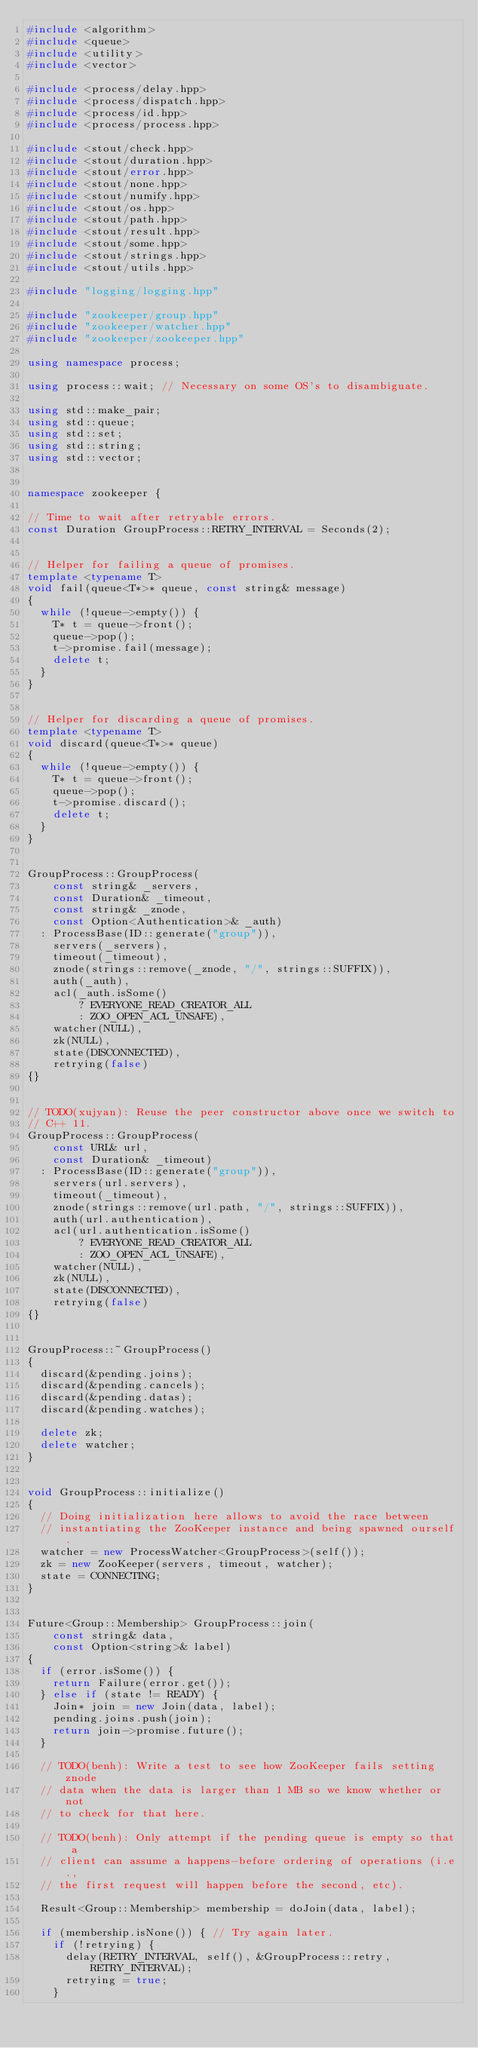<code> <loc_0><loc_0><loc_500><loc_500><_C++_>#include <algorithm>
#include <queue>
#include <utility>
#include <vector>

#include <process/delay.hpp>
#include <process/dispatch.hpp>
#include <process/id.hpp>
#include <process/process.hpp>

#include <stout/check.hpp>
#include <stout/duration.hpp>
#include <stout/error.hpp>
#include <stout/none.hpp>
#include <stout/numify.hpp>
#include <stout/os.hpp>
#include <stout/path.hpp>
#include <stout/result.hpp>
#include <stout/some.hpp>
#include <stout/strings.hpp>
#include <stout/utils.hpp>

#include "logging/logging.hpp"

#include "zookeeper/group.hpp"
#include "zookeeper/watcher.hpp"
#include "zookeeper/zookeeper.hpp"

using namespace process;

using process::wait; // Necessary on some OS's to disambiguate.

using std::make_pair;
using std::queue;
using std::set;
using std::string;
using std::vector;


namespace zookeeper {

// Time to wait after retryable errors.
const Duration GroupProcess::RETRY_INTERVAL = Seconds(2);


// Helper for failing a queue of promises.
template <typename T>
void fail(queue<T*>* queue, const string& message)
{
  while (!queue->empty()) {
    T* t = queue->front();
    queue->pop();
    t->promise.fail(message);
    delete t;
  }
}


// Helper for discarding a queue of promises.
template <typename T>
void discard(queue<T*>* queue)
{
  while (!queue->empty()) {
    T* t = queue->front();
    queue->pop();
    t->promise.discard();
    delete t;
  }
}


GroupProcess::GroupProcess(
    const string& _servers,
    const Duration& _timeout,
    const string& _znode,
    const Option<Authentication>& _auth)
  : ProcessBase(ID::generate("group")),
    servers(_servers),
    timeout(_timeout),
    znode(strings::remove(_znode, "/", strings::SUFFIX)),
    auth(_auth),
    acl(_auth.isSome()
        ? EVERYONE_READ_CREATOR_ALL
        : ZOO_OPEN_ACL_UNSAFE),
    watcher(NULL),
    zk(NULL),
    state(DISCONNECTED),
    retrying(false)
{}


// TODO(xujyan): Reuse the peer constructor above once we switch to
// C++ 11.
GroupProcess::GroupProcess(
    const URL& url,
    const Duration& _timeout)
  : ProcessBase(ID::generate("group")),
    servers(url.servers),
    timeout(_timeout),
    znode(strings::remove(url.path, "/", strings::SUFFIX)),
    auth(url.authentication),
    acl(url.authentication.isSome()
        ? EVERYONE_READ_CREATOR_ALL
        : ZOO_OPEN_ACL_UNSAFE),
    watcher(NULL),
    zk(NULL),
    state(DISCONNECTED),
    retrying(false)
{}


GroupProcess::~GroupProcess()
{
  discard(&pending.joins);
  discard(&pending.cancels);
  discard(&pending.datas);
  discard(&pending.watches);

  delete zk;
  delete watcher;
}


void GroupProcess::initialize()
{
  // Doing initialization here allows to avoid the race between
  // instantiating the ZooKeeper instance and being spawned ourself.
  watcher = new ProcessWatcher<GroupProcess>(self());
  zk = new ZooKeeper(servers, timeout, watcher);
  state = CONNECTING;
}


Future<Group::Membership> GroupProcess::join(
    const string& data,
    const Option<string>& label)
{
  if (error.isSome()) {
    return Failure(error.get());
  } else if (state != READY) {
    Join* join = new Join(data, label);
    pending.joins.push(join);
    return join->promise.future();
  }

  // TODO(benh): Write a test to see how ZooKeeper fails setting znode
  // data when the data is larger than 1 MB so we know whether or not
  // to check for that here.

  // TODO(benh): Only attempt if the pending queue is empty so that a
  // client can assume a happens-before ordering of operations (i.e.,
  // the first request will happen before the second, etc).

  Result<Group::Membership> membership = doJoin(data, label);

  if (membership.isNone()) { // Try again later.
    if (!retrying) {
      delay(RETRY_INTERVAL, self(), &GroupProcess::retry, RETRY_INTERVAL);
      retrying = true;
    }</code> 